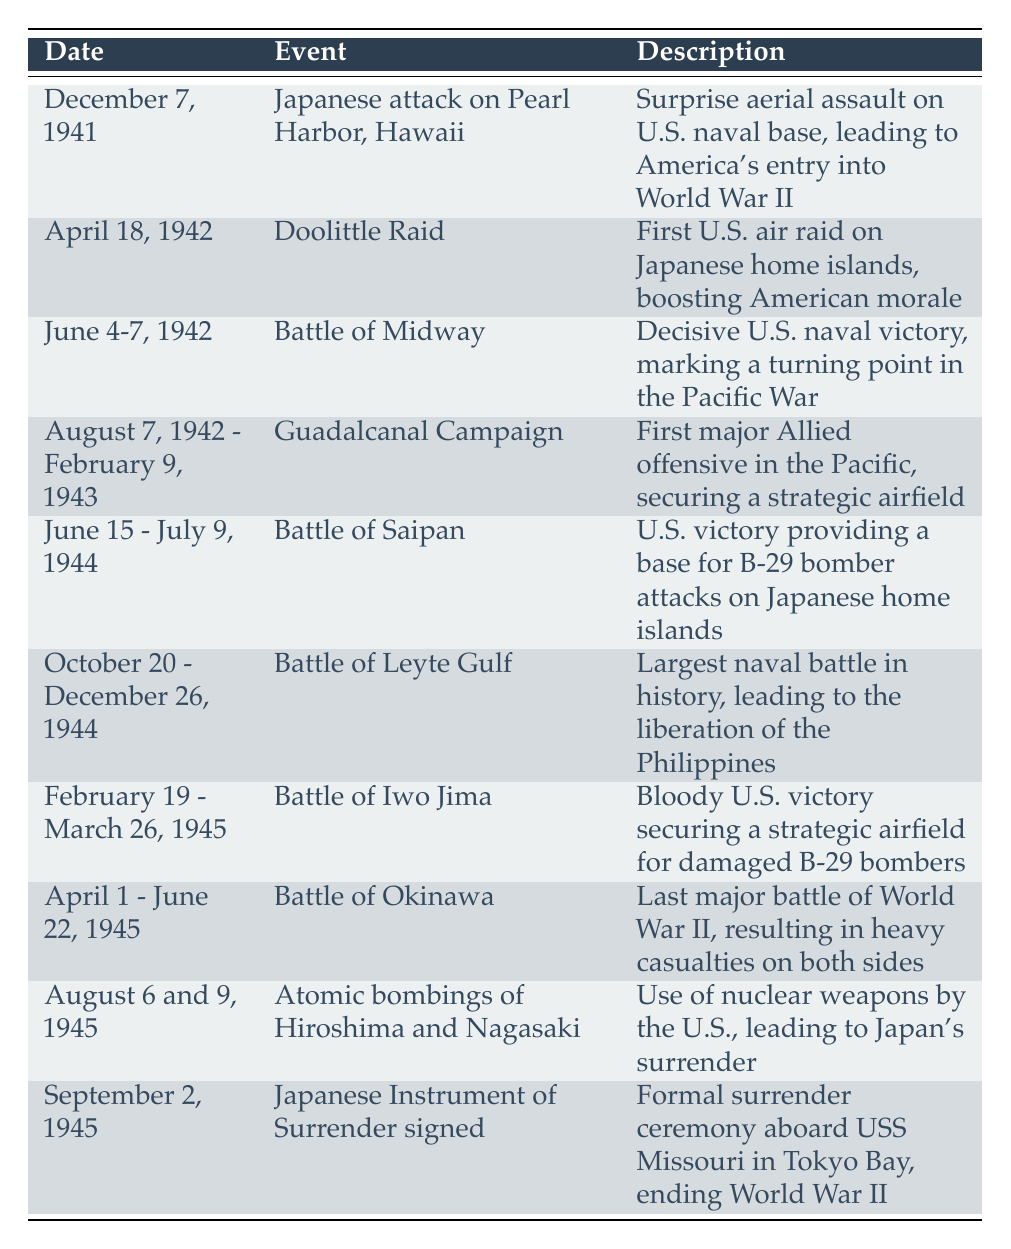What event marked America's entry into World War II? The table indicates that the event marking America's entry was the Japanese attack on Pearl Harbor on December 7, 1941. This is reflected in the "Event" column.
Answer: Japanese attack on Pearl Harbor, Hawaii Which battle is cited as a turning point in the Pacific War? The Battle of Midway, occurring from June 4-7, 1942, is noted in the table as a decisive U.S. naval victory that marked a turning point in the Pacific War, which is found in both the "Event" and "Description" columns.
Answer: Battle of Midway How many atomic bombings are listed in the timeline? The table shows that there are two atomic bombings listed: Hiroshima and Nagasaki on August 6 and 9, 1945. Therefore, the total is two events.
Answer: 2 Which battle occurred last before the signing of the Japanese Instrument of Surrender? The last battle listed before the formal surrender is the Battle of Okinawa, which took place from April 1 to June 22, 1945. This can be found by looking at the "Date" column and identifying the placement of the events.
Answer: Battle of Okinawa What was the major outcome of the Battle of Leyte Gulf? According to the table, the major outcome of the Battle of Leyte Gulf was the liberation of the Philippines. This is clearly stated in the "Description" section related to this event.
Answer: Liberation of the Philippines How many weeks did the Guadalcanal Campaign last? The Guadalcanal Campaign is noted in the table as lasting from August 7, 1942, to February 9, 1943. To find the duration, count the number of weeks between these dates, which spans approximately 26 weeks. This information requires analyzing the date range given in the "Date" column.
Answer: 26 weeks Is it true that the Doolittle Raid was the first air raid on Japan? The description for the Doolittle Raid indicates it was the first U.S. air raid on Japanese home islands, confirming that the statement is true based on the table's information.
Answer: Yes Which event occurred over the longest timeframe? By comparing the durations listed in the "Date" column, the Guadalcanal Campaign covers the longest timeframe, from August 7, 1942, to February 9, 1943, meaning its duration far exceeds other single events presented in the table.
Answer: Guadalcanal Campaign 